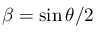Convert formula to latex. <formula><loc_0><loc_0><loc_500><loc_500>\beta = \sin { \theta / 2 }</formula> 